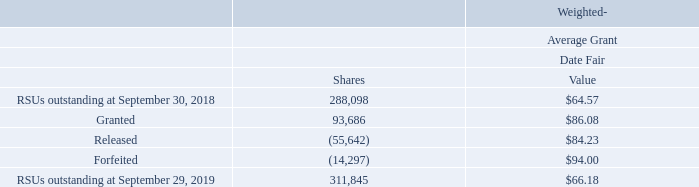Beginning fiscal 2011, we replaced the ownership share grants with time-vested RSUs for certain Vice Presidents and Officers that vest ratably overfour to five years and have a 50% or 100% holding requirement on settled shares, which must be held until termination. There were146,268 of such RSUs outstanding as of September 29, 2019. RSUs issued to non-management directors and certain other employees vest12 months from the date of grant, or upon termination of board service if the director or employee elects to defer receipt, and totaled 69,411 units outstanding as of September 29, 2019. RSUs issued to certain other employees either cliff vest or vest ratably over three years and totaled 35,864 units outstanding as of September 29, 2019. These awards are amortized to compensation expense over the estimated vesting period based upon the fair value of our common stock on the award date discounted by the present value of the expected dividend stream over the vesting period.
The following is a summary of RSU activity for fiscal 2019:
As of September 29, 2019, there was approximately $7.4 million of total unrecognized compensation cost related to RSUs, which is expected to be recognized over a weighted-average period of 2.2 years. The weighted-average grant date fair value of awards granted was$86.08, $94.93, and $102.42 in fiscal years 2019, 2018, and 2017, respectively. In fiscal years 2019, 2018, and 2017, the total fair value of RSUs that vested and were released was$4.7 million, $4.4 million, and $4.4 million, respectively.
What is the weighted-average grant date fair value of awards granted in fiscal year 2017? $102.42. What is the total fair value of RSUs that were vested and released in fiscal year 2019? $4.7 million. What is the total number of RSUs outstanding at September 29, 2019? 311,845. What is the difference in the weighted-average grant date fair value between granted RSUs and released RSUs? 86.08-84.23
Answer: 1.85. What is the percentage change of RSUs outstanding from September 30, 2018 to September 29, 2019?
Answer scale should be: percent. (311,845-288,098)/288,098
Answer: 8.24. What is the total fair value of RSUs outstanding at September 29, 2019? 311,845*$66.18
Answer: 20637902.1. 